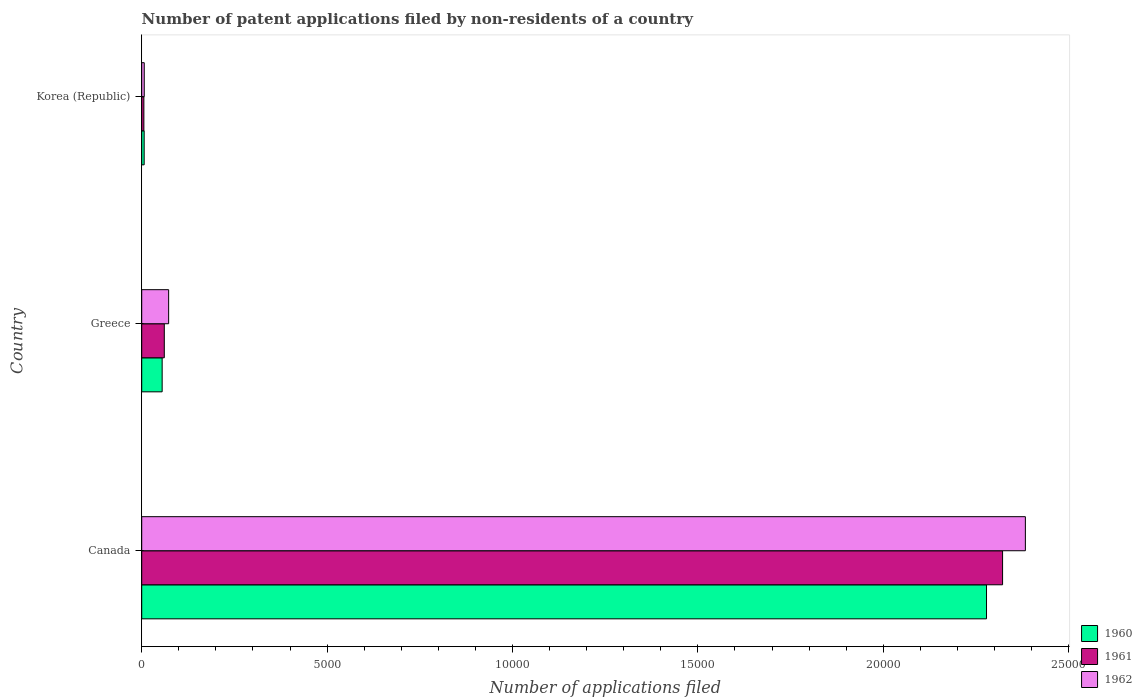How many different coloured bars are there?
Your answer should be very brief. 3. Are the number of bars on each tick of the Y-axis equal?
Make the answer very short. Yes. How many bars are there on the 2nd tick from the bottom?
Ensure brevity in your answer.  3. What is the label of the 3rd group of bars from the top?
Your response must be concise. Canada. What is the number of applications filed in 1962 in Canada?
Give a very brief answer. 2.38e+04. Across all countries, what is the maximum number of applications filed in 1960?
Offer a very short reply. 2.28e+04. What is the total number of applications filed in 1961 in the graph?
Offer a terse response. 2.39e+04. What is the difference between the number of applications filed in 1962 in Canada and that in Korea (Republic)?
Keep it short and to the point. 2.38e+04. What is the difference between the number of applications filed in 1961 in Greece and the number of applications filed in 1960 in Korea (Republic)?
Ensure brevity in your answer.  543. What is the average number of applications filed in 1961 per country?
Provide a succinct answer. 7962. What is the ratio of the number of applications filed in 1962 in Canada to that in Korea (Republic)?
Your response must be concise. 350.5. What is the difference between the highest and the second highest number of applications filed in 1962?
Your response must be concise. 2.31e+04. What is the difference between the highest and the lowest number of applications filed in 1962?
Give a very brief answer. 2.38e+04. Is the sum of the number of applications filed in 1961 in Greece and Korea (Republic) greater than the maximum number of applications filed in 1962 across all countries?
Offer a terse response. No. What does the 2nd bar from the top in Canada represents?
Your answer should be compact. 1961. Is it the case that in every country, the sum of the number of applications filed in 1961 and number of applications filed in 1962 is greater than the number of applications filed in 1960?
Your response must be concise. Yes. How many countries are there in the graph?
Offer a terse response. 3. Are the values on the major ticks of X-axis written in scientific E-notation?
Give a very brief answer. No. How are the legend labels stacked?
Ensure brevity in your answer.  Vertical. What is the title of the graph?
Your answer should be compact. Number of patent applications filed by non-residents of a country. What is the label or title of the X-axis?
Make the answer very short. Number of applications filed. What is the label or title of the Y-axis?
Provide a short and direct response. Country. What is the Number of applications filed of 1960 in Canada?
Give a very brief answer. 2.28e+04. What is the Number of applications filed in 1961 in Canada?
Your response must be concise. 2.32e+04. What is the Number of applications filed in 1962 in Canada?
Provide a short and direct response. 2.38e+04. What is the Number of applications filed of 1960 in Greece?
Make the answer very short. 551. What is the Number of applications filed of 1961 in Greece?
Your response must be concise. 609. What is the Number of applications filed in 1962 in Greece?
Make the answer very short. 726. What is the Number of applications filed in 1960 in Korea (Republic)?
Your answer should be compact. 66. What is the Number of applications filed in 1961 in Korea (Republic)?
Give a very brief answer. 58. Across all countries, what is the maximum Number of applications filed in 1960?
Your answer should be very brief. 2.28e+04. Across all countries, what is the maximum Number of applications filed in 1961?
Keep it short and to the point. 2.32e+04. Across all countries, what is the maximum Number of applications filed in 1962?
Keep it short and to the point. 2.38e+04. Across all countries, what is the minimum Number of applications filed in 1961?
Your answer should be very brief. 58. What is the total Number of applications filed in 1960 in the graph?
Ensure brevity in your answer.  2.34e+04. What is the total Number of applications filed of 1961 in the graph?
Offer a terse response. 2.39e+04. What is the total Number of applications filed of 1962 in the graph?
Ensure brevity in your answer.  2.46e+04. What is the difference between the Number of applications filed in 1960 in Canada and that in Greece?
Offer a very short reply. 2.22e+04. What is the difference between the Number of applications filed of 1961 in Canada and that in Greece?
Ensure brevity in your answer.  2.26e+04. What is the difference between the Number of applications filed in 1962 in Canada and that in Greece?
Provide a succinct answer. 2.31e+04. What is the difference between the Number of applications filed of 1960 in Canada and that in Korea (Republic)?
Provide a succinct answer. 2.27e+04. What is the difference between the Number of applications filed in 1961 in Canada and that in Korea (Republic)?
Your answer should be compact. 2.32e+04. What is the difference between the Number of applications filed in 1962 in Canada and that in Korea (Republic)?
Offer a very short reply. 2.38e+04. What is the difference between the Number of applications filed of 1960 in Greece and that in Korea (Republic)?
Offer a terse response. 485. What is the difference between the Number of applications filed in 1961 in Greece and that in Korea (Republic)?
Your answer should be compact. 551. What is the difference between the Number of applications filed of 1962 in Greece and that in Korea (Republic)?
Your answer should be very brief. 658. What is the difference between the Number of applications filed in 1960 in Canada and the Number of applications filed in 1961 in Greece?
Give a very brief answer. 2.22e+04. What is the difference between the Number of applications filed in 1960 in Canada and the Number of applications filed in 1962 in Greece?
Provide a succinct answer. 2.21e+04. What is the difference between the Number of applications filed of 1961 in Canada and the Number of applications filed of 1962 in Greece?
Provide a succinct answer. 2.25e+04. What is the difference between the Number of applications filed of 1960 in Canada and the Number of applications filed of 1961 in Korea (Republic)?
Your answer should be compact. 2.27e+04. What is the difference between the Number of applications filed of 1960 in Canada and the Number of applications filed of 1962 in Korea (Republic)?
Offer a very short reply. 2.27e+04. What is the difference between the Number of applications filed of 1961 in Canada and the Number of applications filed of 1962 in Korea (Republic)?
Give a very brief answer. 2.32e+04. What is the difference between the Number of applications filed in 1960 in Greece and the Number of applications filed in 1961 in Korea (Republic)?
Your answer should be compact. 493. What is the difference between the Number of applications filed of 1960 in Greece and the Number of applications filed of 1962 in Korea (Republic)?
Your answer should be compact. 483. What is the difference between the Number of applications filed in 1961 in Greece and the Number of applications filed in 1962 in Korea (Republic)?
Ensure brevity in your answer.  541. What is the average Number of applications filed in 1960 per country?
Offer a very short reply. 7801. What is the average Number of applications filed of 1961 per country?
Provide a short and direct response. 7962. What is the average Number of applications filed of 1962 per country?
Provide a short and direct response. 8209.33. What is the difference between the Number of applications filed in 1960 and Number of applications filed in 1961 in Canada?
Offer a very short reply. -433. What is the difference between the Number of applications filed of 1960 and Number of applications filed of 1962 in Canada?
Provide a succinct answer. -1048. What is the difference between the Number of applications filed of 1961 and Number of applications filed of 1962 in Canada?
Your response must be concise. -615. What is the difference between the Number of applications filed of 1960 and Number of applications filed of 1961 in Greece?
Provide a succinct answer. -58. What is the difference between the Number of applications filed in 1960 and Number of applications filed in 1962 in Greece?
Your answer should be compact. -175. What is the difference between the Number of applications filed of 1961 and Number of applications filed of 1962 in Greece?
Your answer should be compact. -117. What is the difference between the Number of applications filed in 1960 and Number of applications filed in 1962 in Korea (Republic)?
Your answer should be very brief. -2. What is the ratio of the Number of applications filed in 1960 in Canada to that in Greece?
Provide a succinct answer. 41.35. What is the ratio of the Number of applications filed in 1961 in Canada to that in Greece?
Your response must be concise. 38.13. What is the ratio of the Number of applications filed of 1962 in Canada to that in Greece?
Provide a succinct answer. 32.83. What is the ratio of the Number of applications filed of 1960 in Canada to that in Korea (Republic)?
Your response must be concise. 345.24. What is the ratio of the Number of applications filed in 1961 in Canada to that in Korea (Republic)?
Offer a very short reply. 400.33. What is the ratio of the Number of applications filed of 1962 in Canada to that in Korea (Republic)?
Your response must be concise. 350.5. What is the ratio of the Number of applications filed of 1960 in Greece to that in Korea (Republic)?
Your response must be concise. 8.35. What is the ratio of the Number of applications filed of 1962 in Greece to that in Korea (Republic)?
Your answer should be very brief. 10.68. What is the difference between the highest and the second highest Number of applications filed of 1960?
Your answer should be compact. 2.22e+04. What is the difference between the highest and the second highest Number of applications filed in 1961?
Offer a terse response. 2.26e+04. What is the difference between the highest and the second highest Number of applications filed of 1962?
Your answer should be very brief. 2.31e+04. What is the difference between the highest and the lowest Number of applications filed of 1960?
Offer a terse response. 2.27e+04. What is the difference between the highest and the lowest Number of applications filed in 1961?
Your answer should be very brief. 2.32e+04. What is the difference between the highest and the lowest Number of applications filed in 1962?
Make the answer very short. 2.38e+04. 